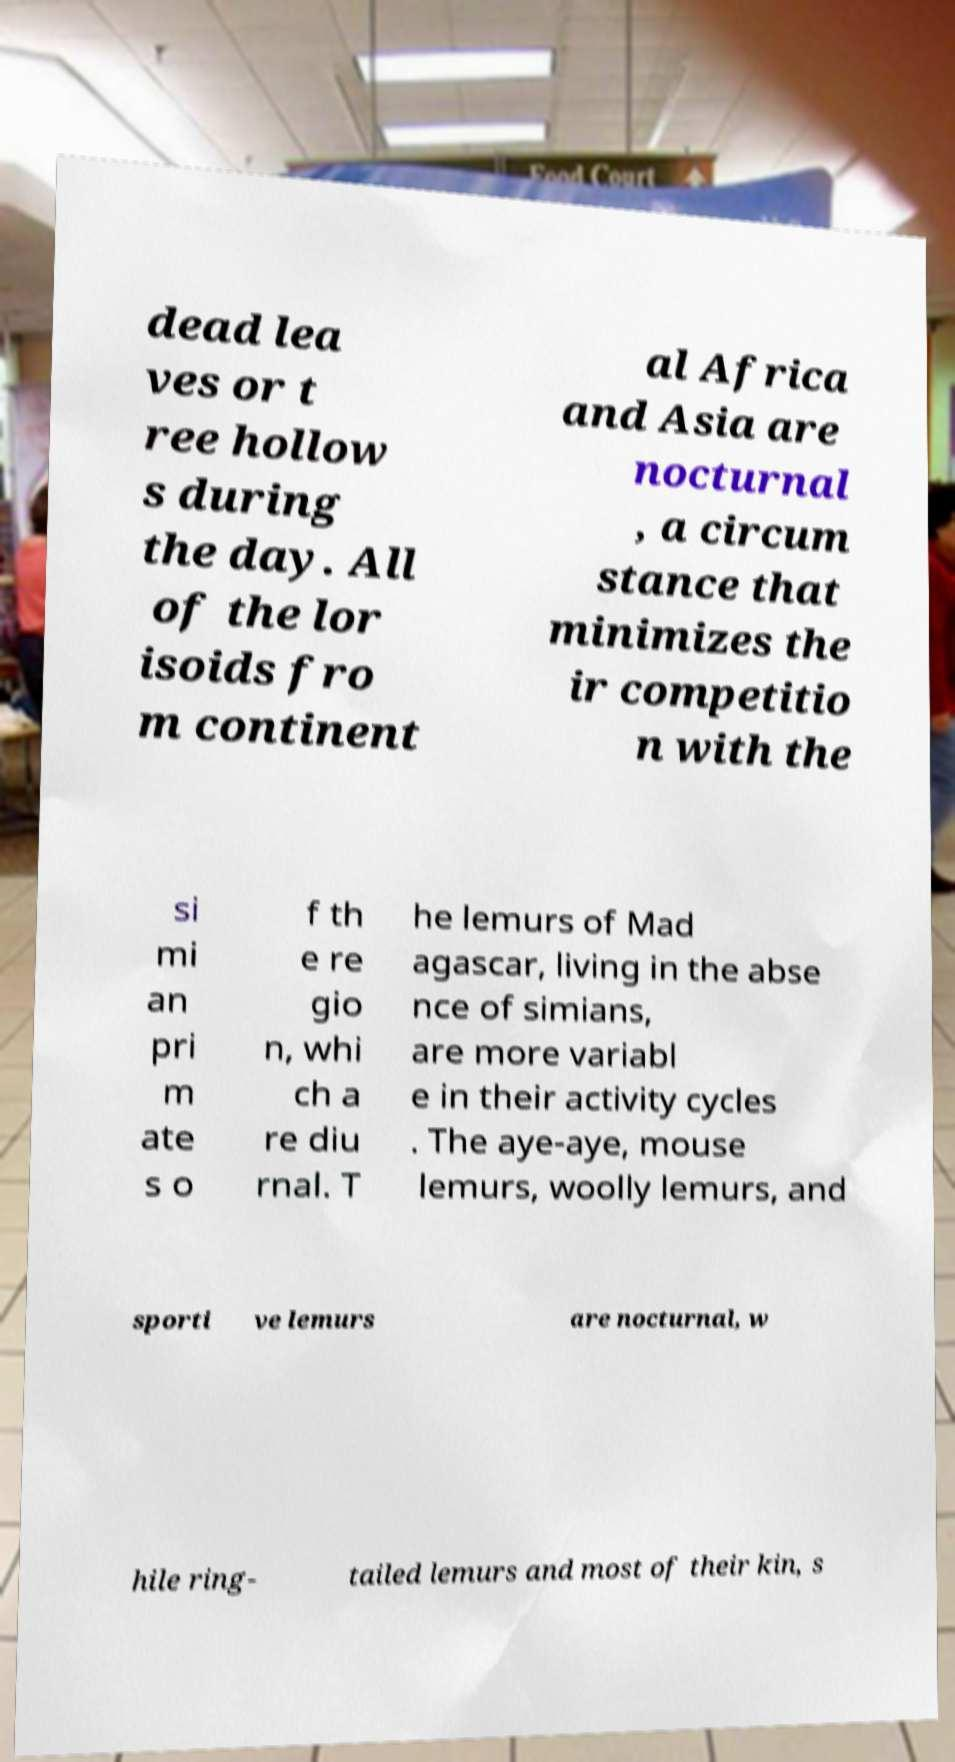I need the written content from this picture converted into text. Can you do that? dead lea ves or t ree hollow s during the day. All of the lor isoids fro m continent al Africa and Asia are nocturnal , a circum stance that minimizes the ir competitio n with the si mi an pri m ate s o f th e re gio n, whi ch a re diu rnal. T he lemurs of Mad agascar, living in the abse nce of simians, are more variabl e in their activity cycles . The aye-aye, mouse lemurs, woolly lemurs, and sporti ve lemurs are nocturnal, w hile ring- tailed lemurs and most of their kin, s 